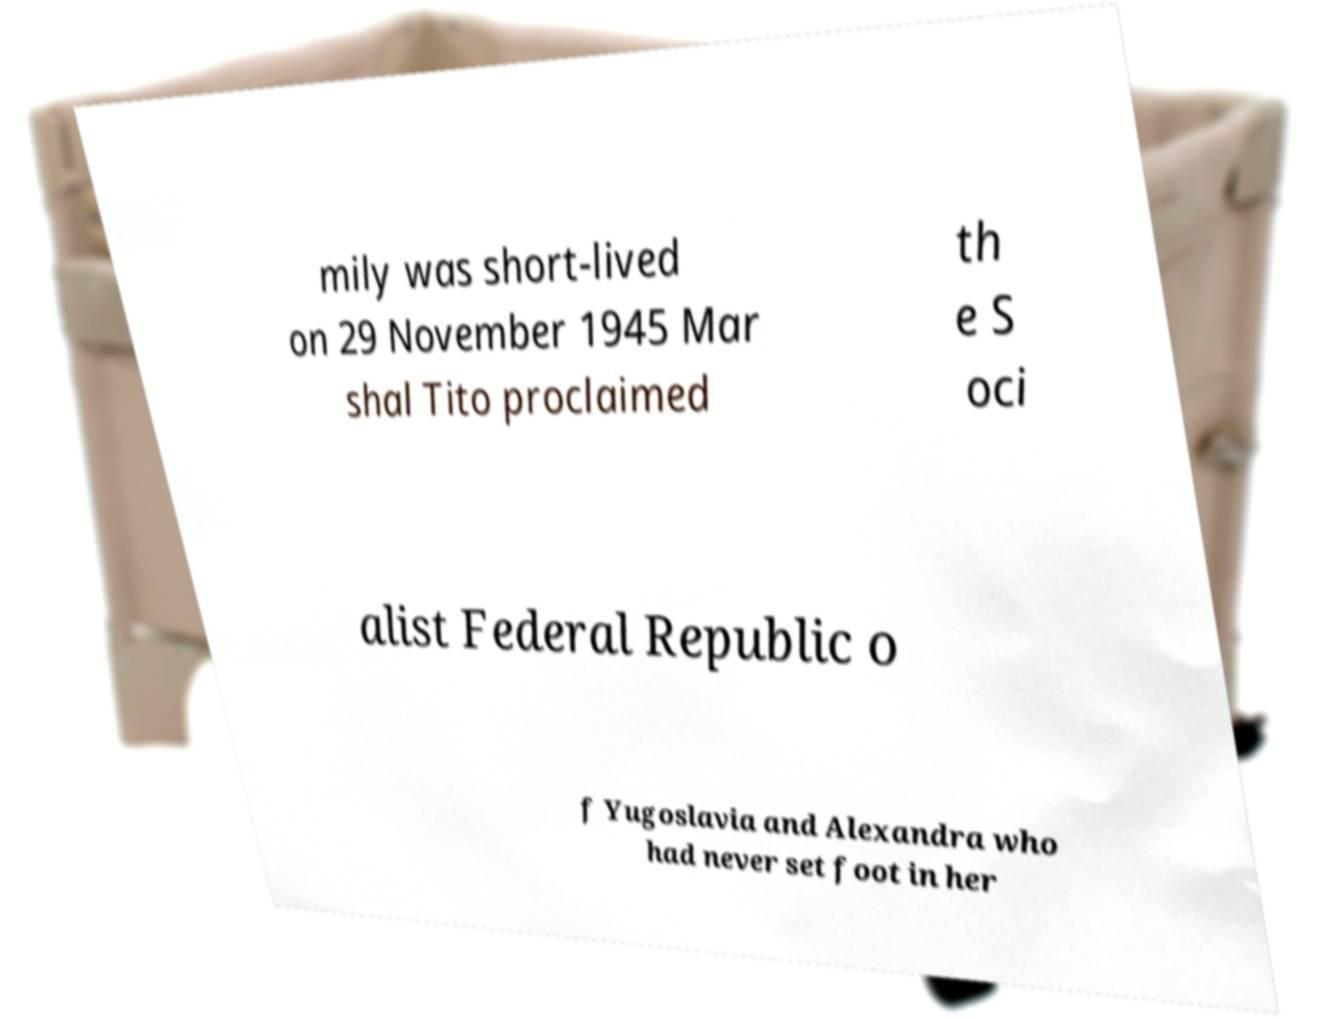Can you read and provide the text displayed in the image?This photo seems to have some interesting text. Can you extract and type it out for me? mily was short-lived on 29 November 1945 Mar shal Tito proclaimed th e S oci alist Federal Republic o f Yugoslavia and Alexandra who had never set foot in her 